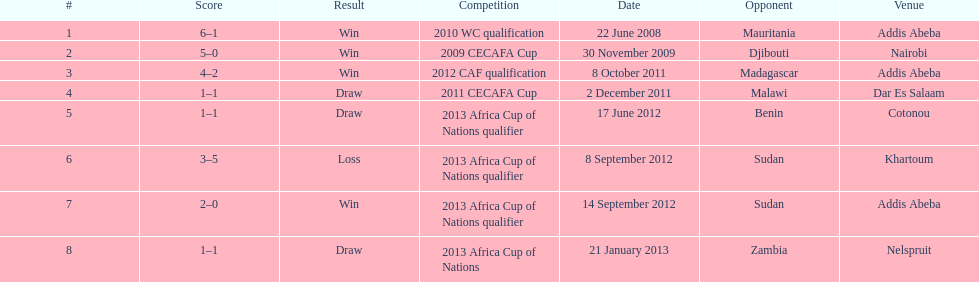Number of different teams listed on the chart 7. 